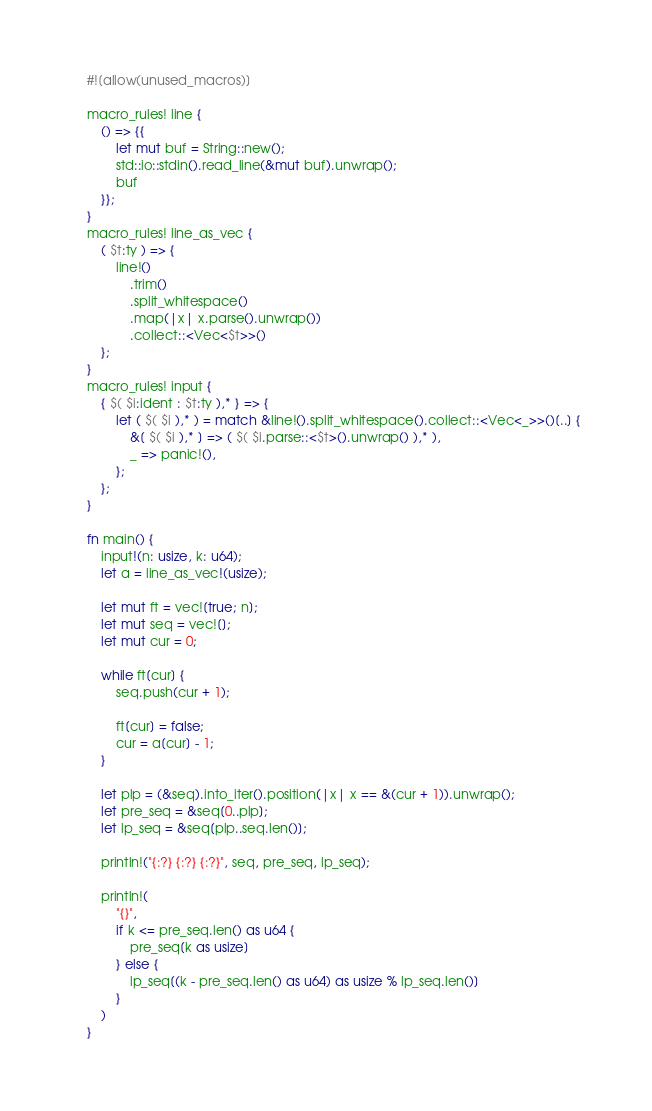Convert code to text. <code><loc_0><loc_0><loc_500><loc_500><_Rust_>#![allow(unused_macros)]

macro_rules! line {
    () => {{
        let mut buf = String::new();
        std::io::stdin().read_line(&mut buf).unwrap();
        buf
    }};
}
macro_rules! line_as_vec {
    ( $t:ty ) => {
        line!()
            .trim()
            .split_whitespace()
            .map(|x| x.parse().unwrap())
            .collect::<Vec<$t>>()
    };
}
macro_rules! input {
    { $( $i:ident : $t:ty ),* } => {
        let ( $( $i ),* ) = match &line!().split_whitespace().collect::<Vec<_>>()[..] {
            &[ $( $i ),* ] => ( $( $i.parse::<$t>().unwrap() ),* ),
            _ => panic!(),
        };
    };
}

fn main() {
    input!(n: usize, k: u64);
    let a = line_as_vec!(usize);

    let mut ft = vec![true; n];
    let mut seq = vec![];
    let mut cur = 0;

    while ft[cur] {
        seq.push(cur + 1);

        ft[cur] = false;
        cur = a[cur] - 1;
    }

    let plp = (&seq).into_iter().position(|x| x == &(cur + 1)).unwrap();
    let pre_seq = &seq[0..plp];
    let lp_seq = &seq[plp..seq.len()];

    println!("{:?} {:?} {:?}", seq, pre_seq, lp_seq);

    println!(
        "{}",
        if k <= pre_seq.len() as u64 {
            pre_seq[k as usize]
        } else {
            lp_seq[(k - pre_seq.len() as u64) as usize % lp_seq.len()]
        }
    )
}
</code> 